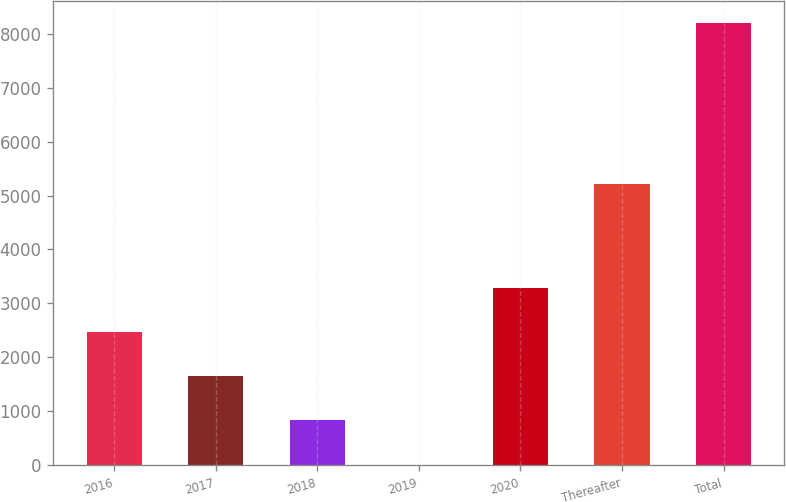Convert chart. <chart><loc_0><loc_0><loc_500><loc_500><bar_chart><fcel>2016<fcel>2017<fcel>2018<fcel>2019<fcel>2020<fcel>Thereafter<fcel>Total<nl><fcel>2468.1<fcel>1648.4<fcel>828.7<fcel>9<fcel>3287.8<fcel>5206<fcel>8206<nl></chart> 